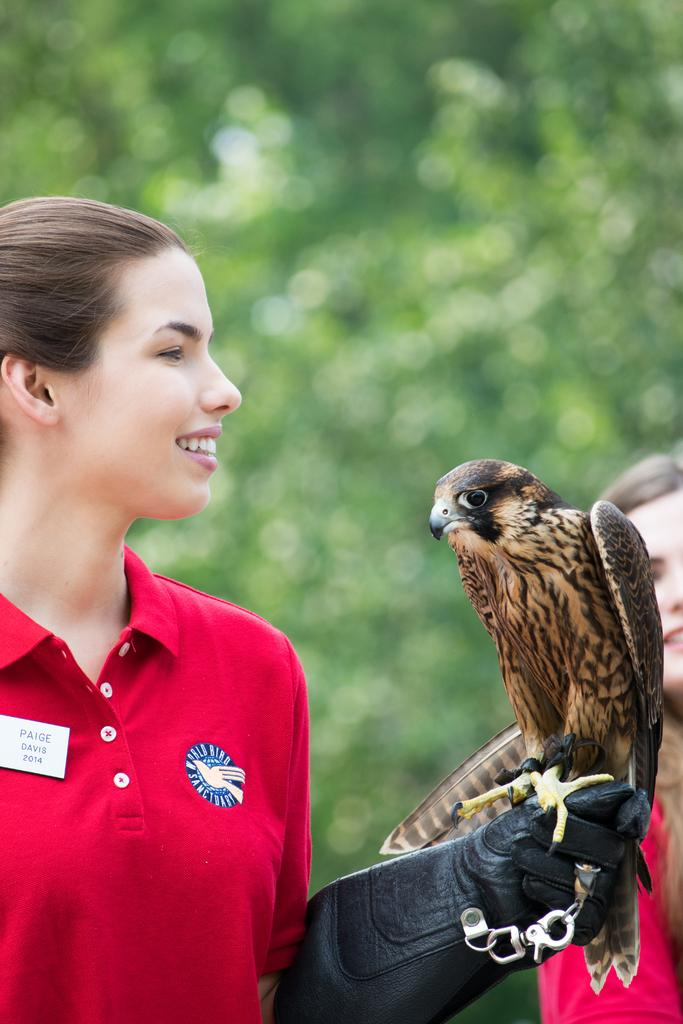How many people are in the image? There are two women in the image. What is the bird doing in the image? The bird is on a glove in the image. Can you describe the background of the image? The background of the image is blurred, and there is greenery visible. What type of power does the partner of the woman in the image have? There is no mention of a partner or power in the image, so it cannot be determined from the image. 